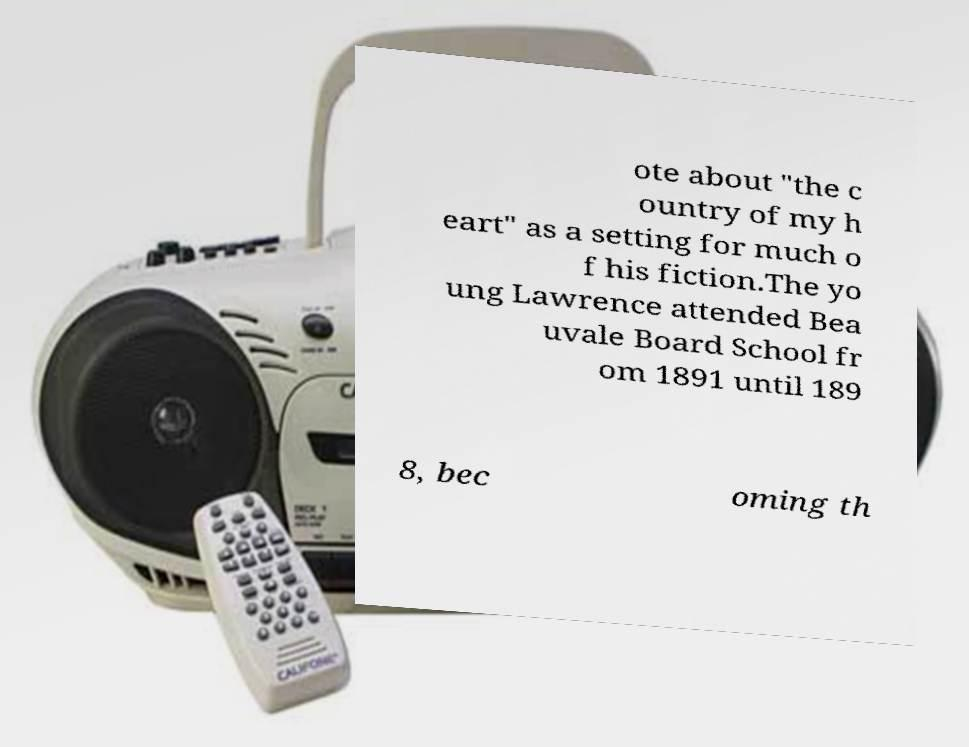What messages or text are displayed in this image? I need them in a readable, typed format. ote about "the c ountry of my h eart" as a setting for much o f his fiction.The yo ung Lawrence attended Bea uvale Board School fr om 1891 until 189 8, bec oming th 